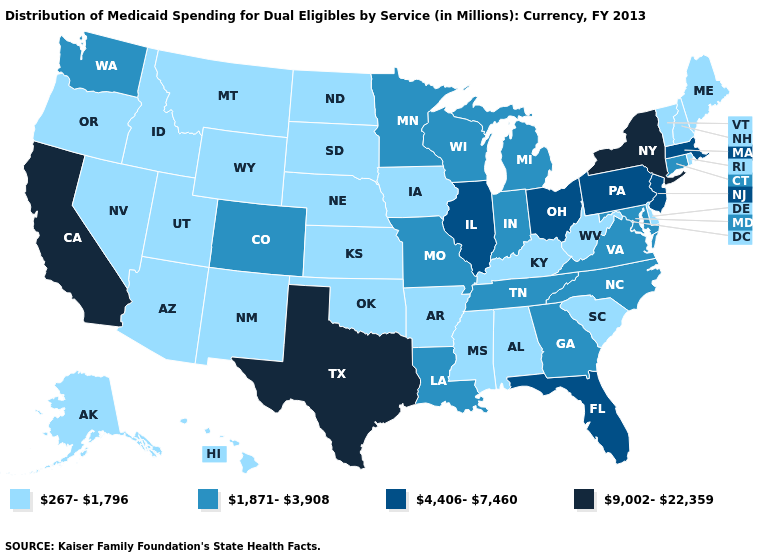Does North Dakota have a lower value than Connecticut?
Short answer required. Yes. Does North Carolina have the lowest value in the USA?
Be succinct. No. Does Iowa have a lower value than Hawaii?
Keep it brief. No. What is the highest value in the MidWest ?
Be succinct. 4,406-7,460. What is the value of Maine?
Be succinct. 267-1,796. What is the value of Maryland?
Give a very brief answer. 1,871-3,908. What is the lowest value in the West?
Be succinct. 267-1,796. What is the lowest value in states that border Maryland?
Give a very brief answer. 267-1,796. Name the states that have a value in the range 4,406-7,460?
Write a very short answer. Florida, Illinois, Massachusetts, New Jersey, Ohio, Pennsylvania. What is the lowest value in the MidWest?
Give a very brief answer. 267-1,796. What is the value of Delaware?
Short answer required. 267-1,796. What is the value of New Hampshire?
Keep it brief. 267-1,796. Among the states that border Arkansas , which have the highest value?
Give a very brief answer. Texas. Which states have the highest value in the USA?
Quick response, please. California, New York, Texas. Among the states that border Indiana , does Kentucky have the lowest value?
Answer briefly. Yes. 